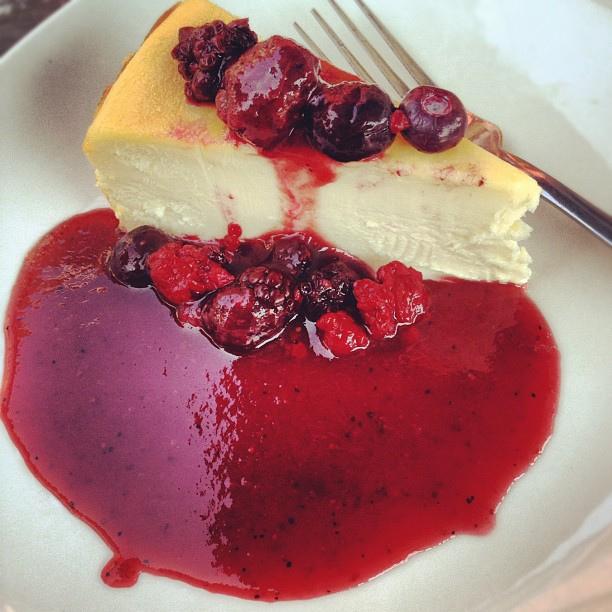Are multiple types of berries on the food?
Keep it brief. Yes. What color is the plate?
Write a very short answer. White. Is this a healthy breakfast?
Keep it brief. No. 